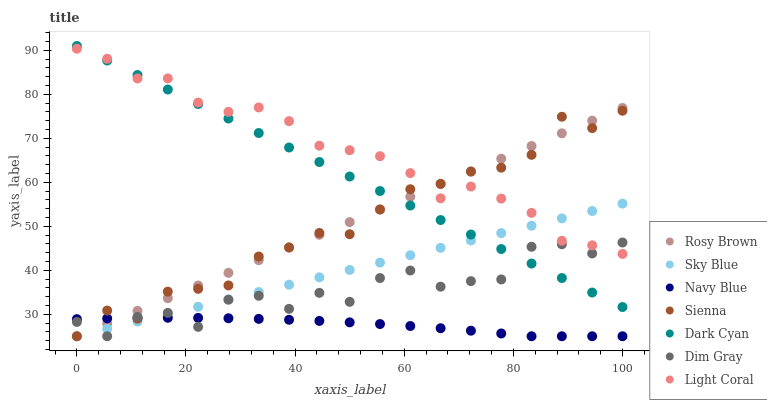Does Navy Blue have the minimum area under the curve?
Answer yes or no. Yes. Does Light Coral have the maximum area under the curve?
Answer yes or no. Yes. Does Dim Gray have the minimum area under the curve?
Answer yes or no. No. Does Dim Gray have the maximum area under the curve?
Answer yes or no. No. Is Sky Blue the smoothest?
Answer yes or no. Yes. Is Dim Gray the roughest?
Answer yes or no. Yes. Is Navy Blue the smoothest?
Answer yes or no. No. Is Navy Blue the roughest?
Answer yes or no. No. Does Dim Gray have the lowest value?
Answer yes or no. Yes. Does Dark Cyan have the lowest value?
Answer yes or no. No. Does Dark Cyan have the highest value?
Answer yes or no. Yes. Does Dim Gray have the highest value?
Answer yes or no. No. Is Navy Blue less than Dark Cyan?
Answer yes or no. Yes. Is Dark Cyan greater than Navy Blue?
Answer yes or no. Yes. Does Rosy Brown intersect Light Coral?
Answer yes or no. Yes. Is Rosy Brown less than Light Coral?
Answer yes or no. No. Is Rosy Brown greater than Light Coral?
Answer yes or no. No. Does Navy Blue intersect Dark Cyan?
Answer yes or no. No. 